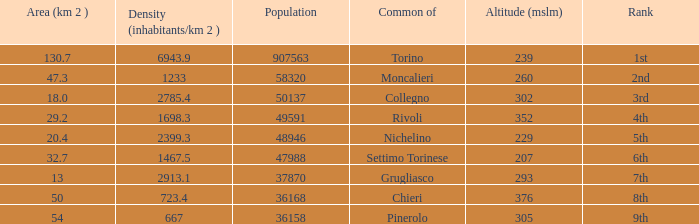The common of Chieri has what population density? 723.4. 